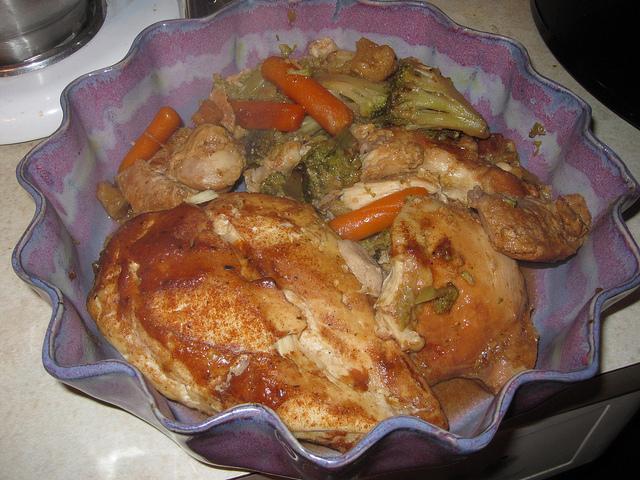Is the caption "The sandwich is at the right side of the bowl." a true representation of the image?
Answer yes or no. No. 